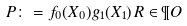<formula> <loc_0><loc_0><loc_500><loc_500>P \colon = f _ { 0 } ( X _ { 0 } ) g _ { 1 } ( X _ { 1 } ) \, R \in \P O</formula> 